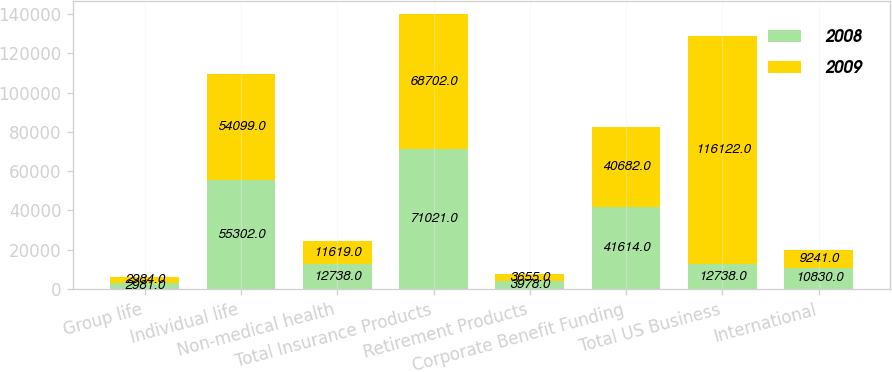Convert chart. <chart><loc_0><loc_0><loc_500><loc_500><stacked_bar_chart><ecel><fcel>Group life<fcel>Individual life<fcel>Non-medical health<fcel>Total Insurance Products<fcel>Retirement Products<fcel>Corporate Benefit Funding<fcel>Total US Business<fcel>International<nl><fcel>2008<fcel>2981<fcel>55302<fcel>12738<fcel>71021<fcel>3978<fcel>41614<fcel>12738<fcel>10830<nl><fcel>2009<fcel>2984<fcel>54099<fcel>11619<fcel>68702<fcel>3655<fcel>40682<fcel>116122<fcel>9241<nl></chart> 